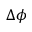<formula> <loc_0><loc_0><loc_500><loc_500>\Delta \phi</formula> 